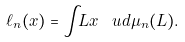Convert formula to latex. <formula><loc_0><loc_0><loc_500><loc_500>\ell _ { n } ( x ) = \int _ { \L } L x \, \ u d \mu _ { n } ( L ) .</formula> 